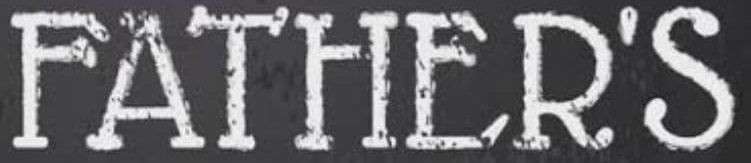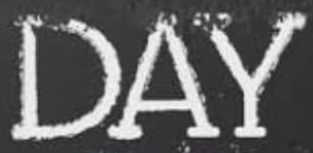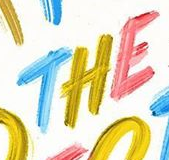Read the text content from these images in order, separated by a semicolon. FATHER'S; DAY; THE 